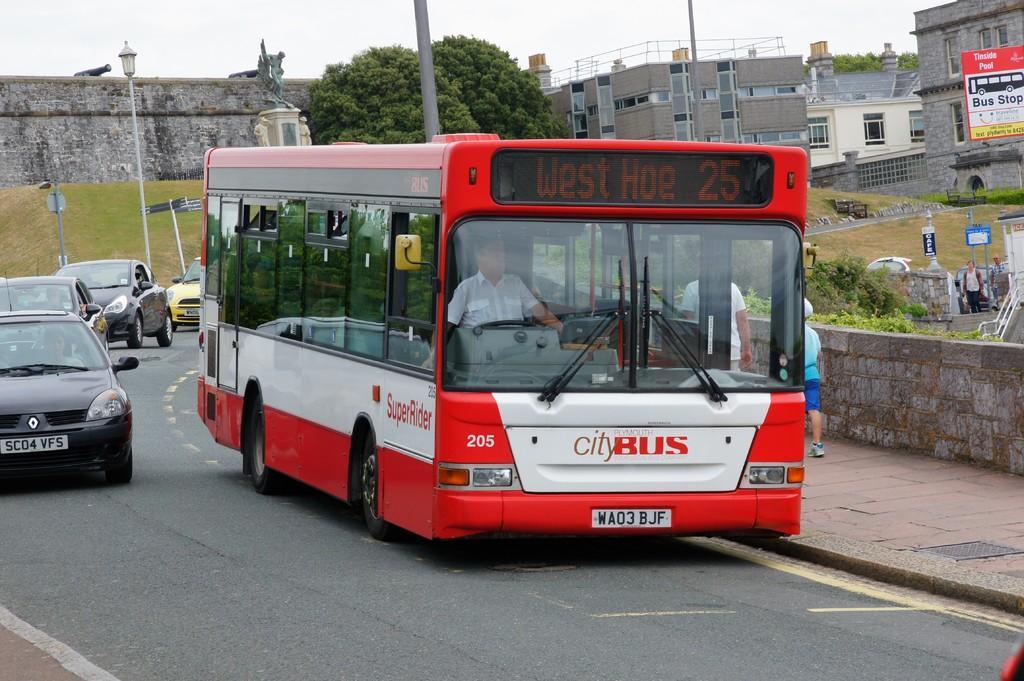In one or two sentences, can you explain what this image depicts? In this image I can see road and on it I can see few cars and a bus. On this bus I can see something is written and I can also see a man in it. In the background I can see few people are standing, plants, boards, buildings, poles, a light and on these boards I can see something is written. 